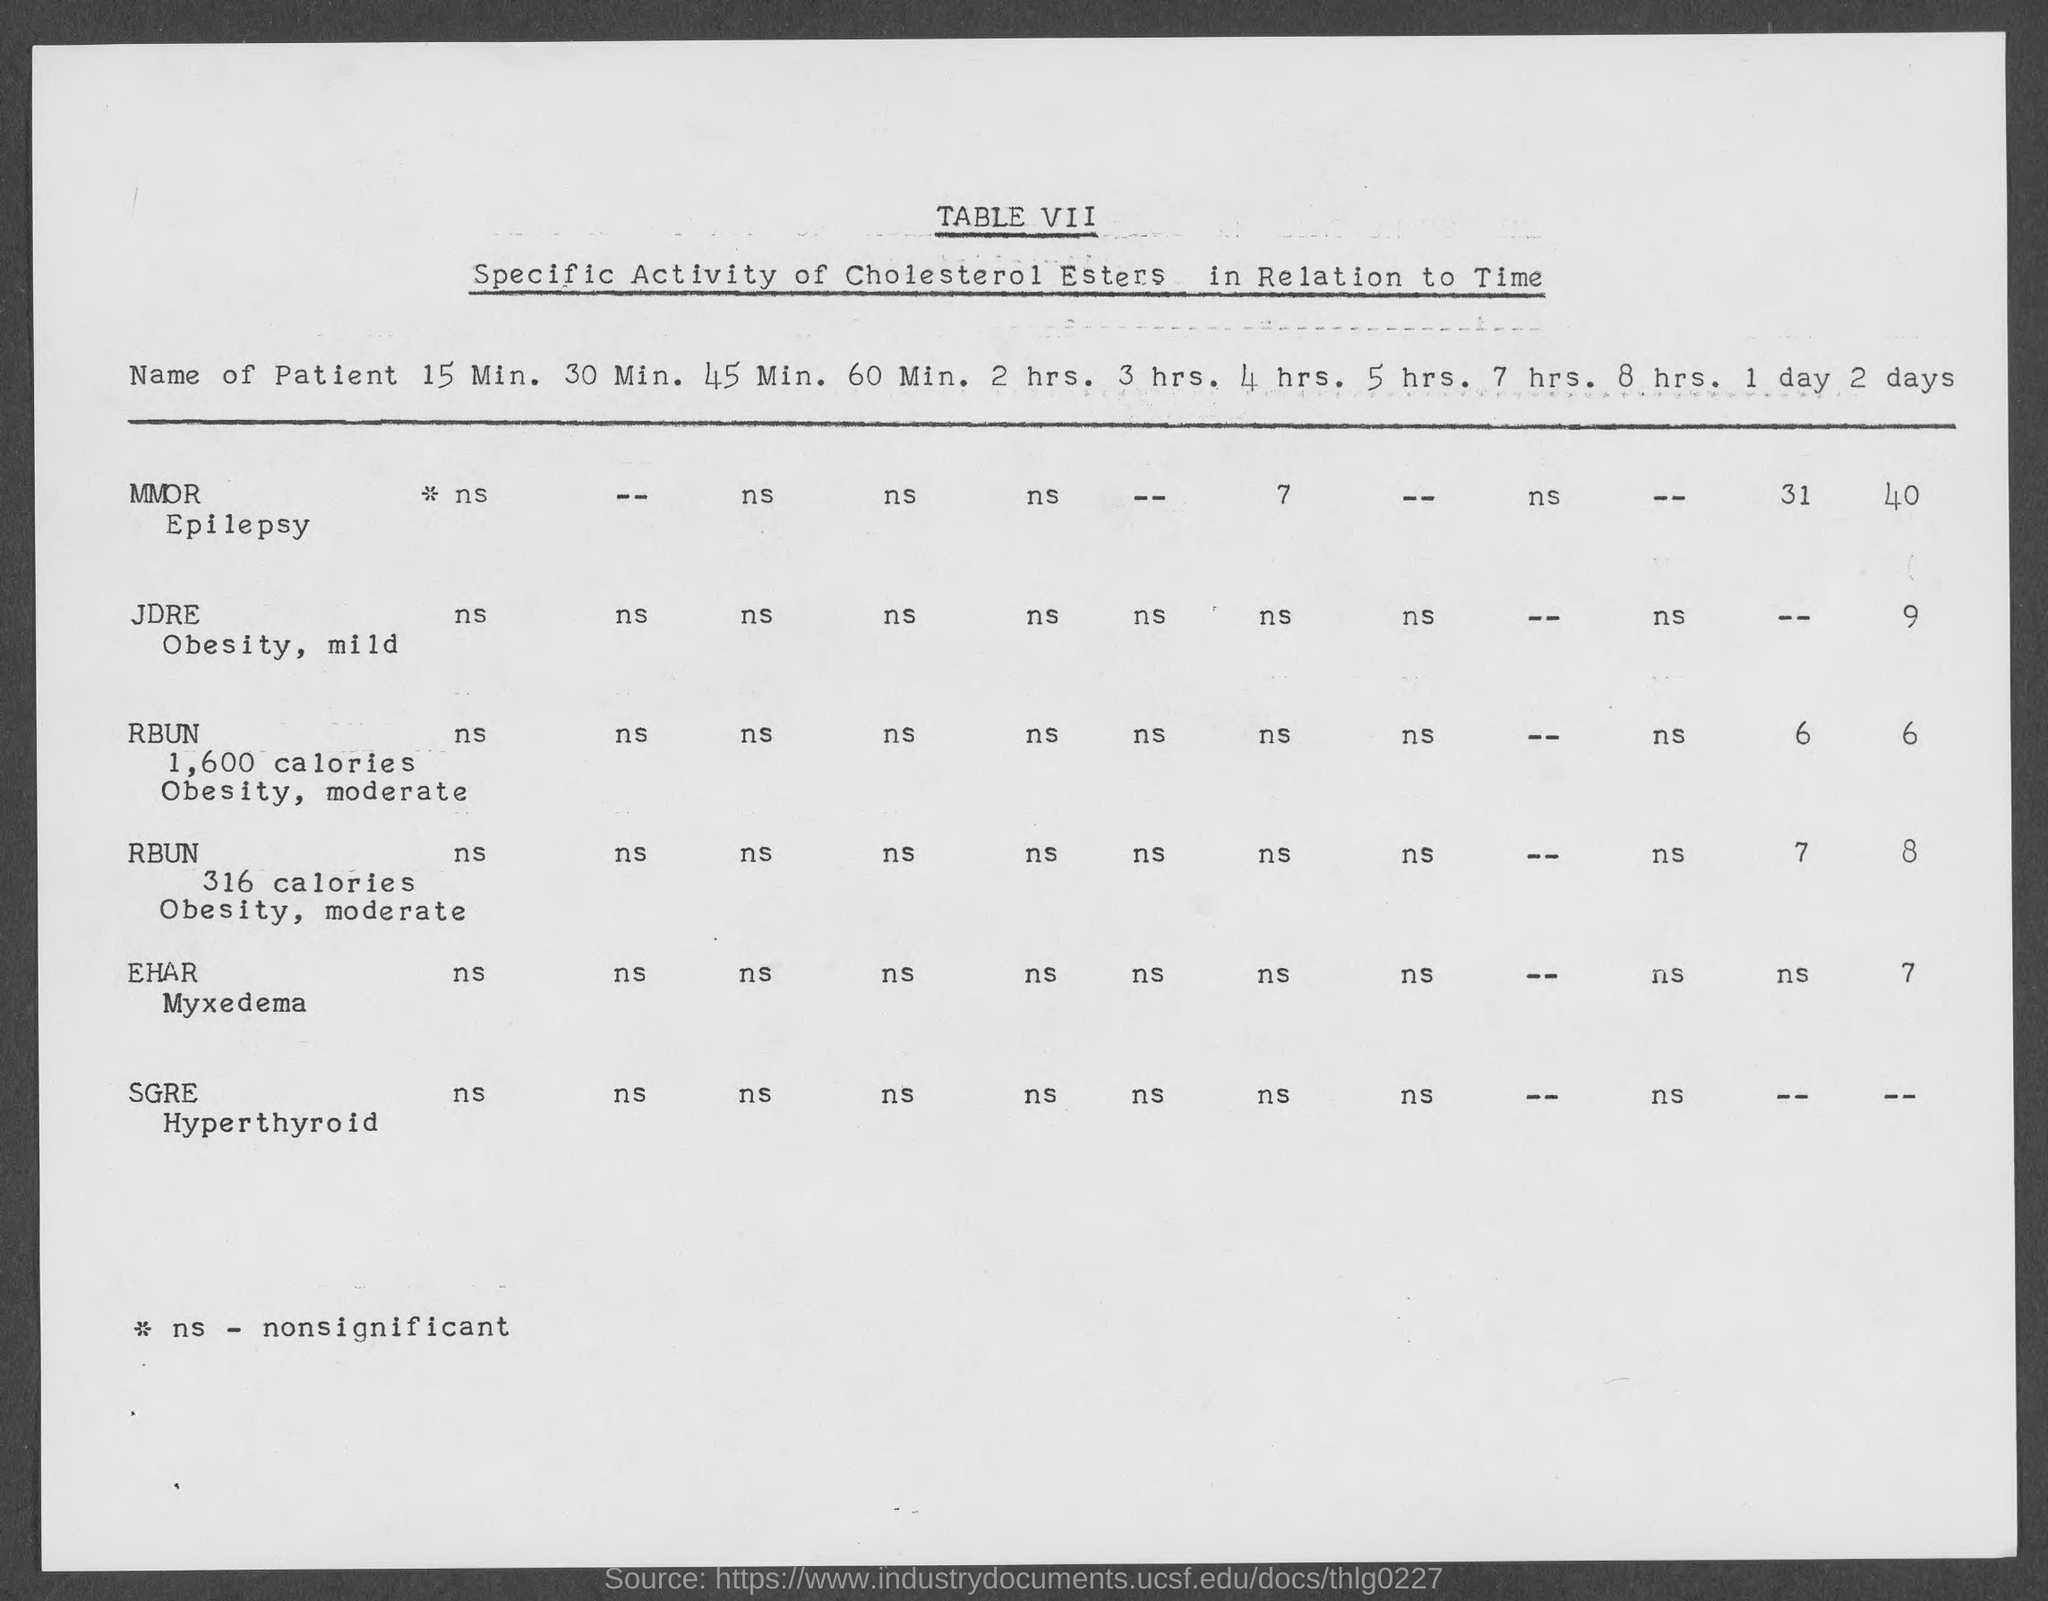List a handful of essential elements in this visual. The specific activity of cholesterol esters has been observed over a period of two days. The last patient in the document is named SGRE. The patient's name is EHAR, and they have Myxedema disease. The title of the table located under the heading "TABLE VII" at the top of the document is "Specific Activity of Cholesterol Esters in Relation to Time. The second patient's name is JDRE. 